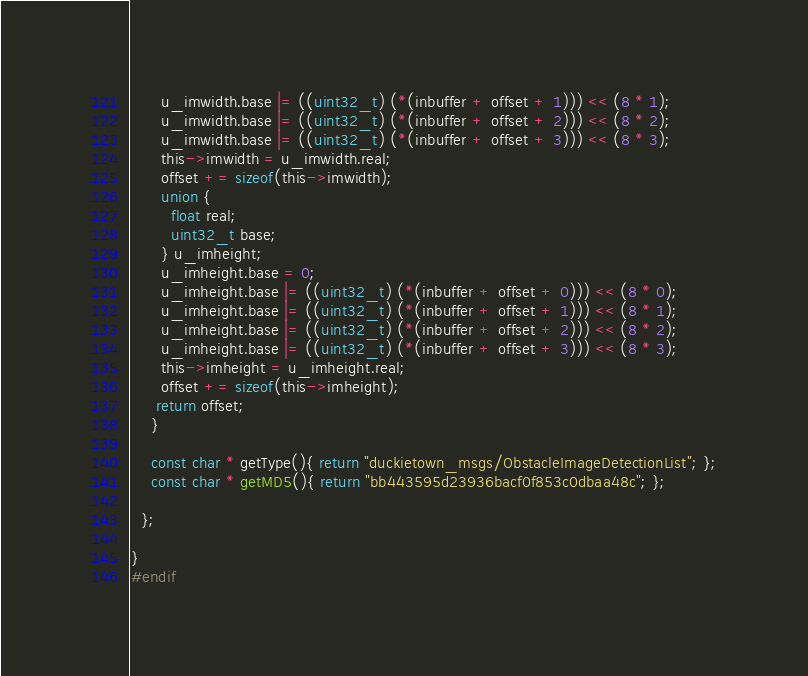Convert code to text. <code><loc_0><loc_0><loc_500><loc_500><_C_>      u_imwidth.base |= ((uint32_t) (*(inbuffer + offset + 1))) << (8 * 1);
      u_imwidth.base |= ((uint32_t) (*(inbuffer + offset + 2))) << (8 * 2);
      u_imwidth.base |= ((uint32_t) (*(inbuffer + offset + 3))) << (8 * 3);
      this->imwidth = u_imwidth.real;
      offset += sizeof(this->imwidth);
      union {
        float real;
        uint32_t base;
      } u_imheight;
      u_imheight.base = 0;
      u_imheight.base |= ((uint32_t) (*(inbuffer + offset + 0))) << (8 * 0);
      u_imheight.base |= ((uint32_t) (*(inbuffer + offset + 1))) << (8 * 1);
      u_imheight.base |= ((uint32_t) (*(inbuffer + offset + 2))) << (8 * 2);
      u_imheight.base |= ((uint32_t) (*(inbuffer + offset + 3))) << (8 * 3);
      this->imheight = u_imheight.real;
      offset += sizeof(this->imheight);
     return offset;
    }

    const char * getType(){ return "duckietown_msgs/ObstacleImageDetectionList"; };
    const char * getMD5(){ return "bb443595d23936bacf0f853c0dbaa48c"; };

  };

}
#endif</code> 